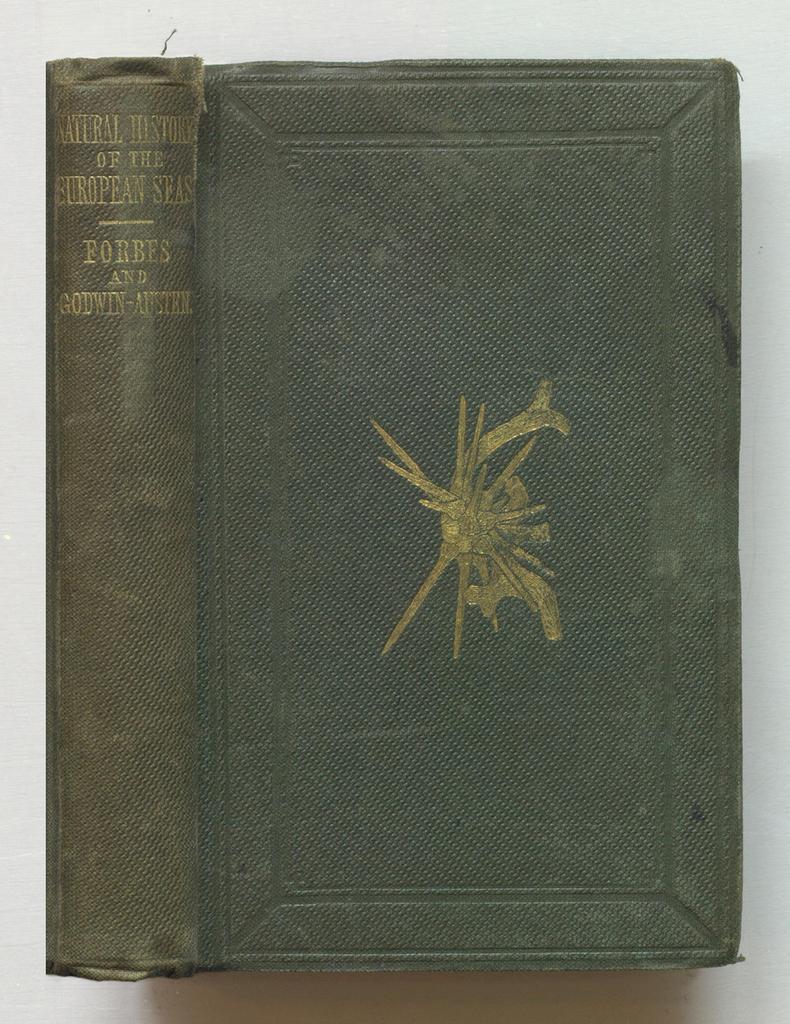What is the title of this book?
Ensure brevity in your answer.  Natural history of the european seas. What is the first author listed on the spine?
Offer a very short reply. Forbes. 